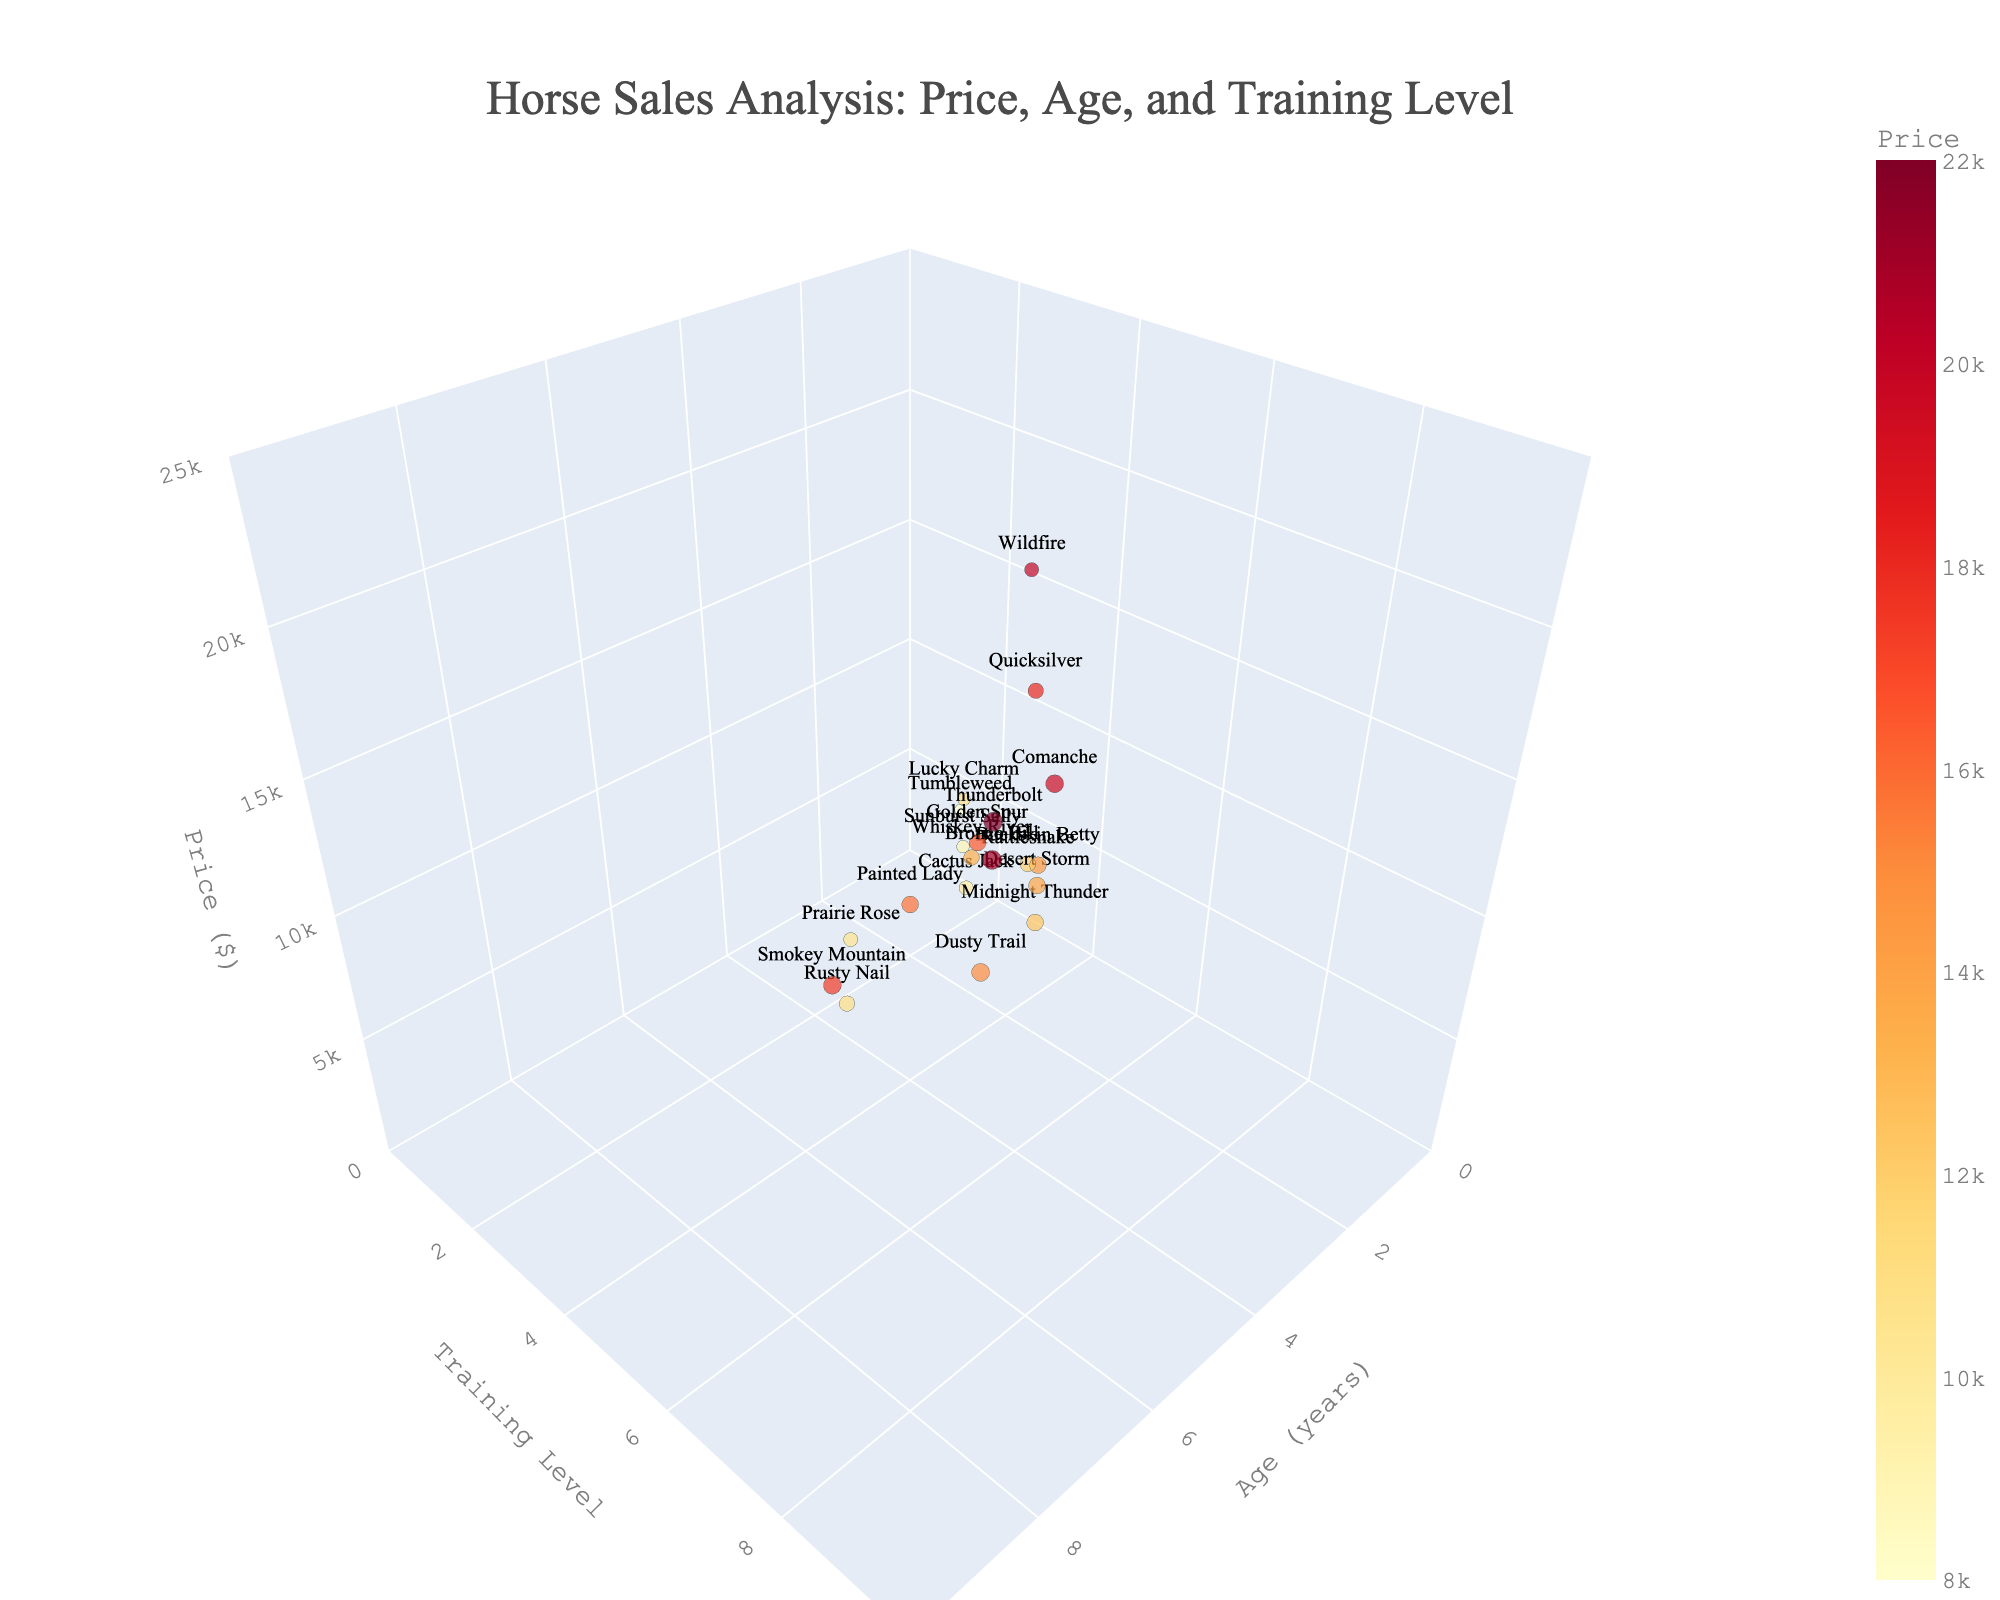How many horses are displayed in the plot? Count the number of individual data points in the 3D scatter plot. There are 20 horses listed in the data table, so there should be 20 points visible in the plot.
Answer: 20 What color scale is used for the plot? Look at the color gradient used to represent the price of the horses. The color scale in the plot ranges from yellow to red, denoted by 'YlOrRd'.
Answer: Yellow to Red (YlOrRd) What are the axis titles in the plot? Identify the titles given to the x-axis, y-axis, and z-axis in the 3D scatter plot. The x-axis is labeled 'Age (years)', the y-axis 'Training Level', and the z-axis 'Price ($)'.
Answer: Age (years), Training Level, Price ($) Which horse has the highest price and what is that price? Find the data point that is the highest on the z-axis, which represents the price. The highest price is associated with 'Thunderbolt' at $22,000.
Answer: Thunderbolt, $22,000 Which training level do Prairie Rose and Quicksilver share? Locate the data points for 'Prairie Rose' and 'Quicksilver' and compare their positions on the y-axis. Both have a training level of 5.
Answer: Training Level 5 What is the average price of horses aged 5 years? Identify all data points where the x-axis (Age) is 5, sum their prices, and divide by the number of such horses. Prices: 12500 (Midnight Thunder), 13500 (Whiskey River), 14500 (Buckskin Betty), 13800 (Desert Storm); Sum = 54300; Average = 54300 / 4 = 13,575
Answer: $13,575 What's the difference in price between the oldest and youngest horse? Identify the data points representing the oldest (Smokey Mountain, 9 years) and youngest (Tumbleweed, 2 years) horses, then subtract the price of the youngest from the price of the oldest. Oldest: 17500, Youngest: 8000; Difference = 17500 - 8000 = 9500
Answer: $9,500 Which horse has the lowest training level? Locate the data point that is the lowest on the y-axis (Training Level). 'Tumbleweed' has the lowest training level at 3.
Answer: Tumbleweed Which two horses have the highest prices among those with a Training Level of 8? Identify all data points where the y-axis (Training Level) is 8, and compare their heights on the z-axis. 'Bronco Bill' ($21,000) and 'Dusty Trail' ($15,000) have the highest prices among horses with Training Level 8.
Answer: Bronco Bill, Dusty Trail What's the average training level of the horses priced above $18,000? Identify data points with prices above $18,000, and calculate the average of their training levels. Horses: Quicksilver (6), Wildfire (5), Comanche (8), Bronco Bill (9); Total Training Levels = 6+5+8+9 = 28; Average = 28 / 4 = 7
Answer: 7 